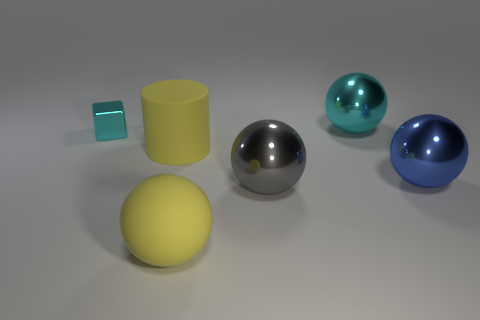How do the textures of the different objects compare? The objects display a variety of textures: the blue and silver spheres have a smooth and reflective surface, indicative of a metallic texture, while the yellow sphere has a more matte finish. The yellow cylinder and the tiny blue cube both have a relatively flat surface, but the cylinder's surface seems slightly reflective, which differs from the cube's more solid appearance. 